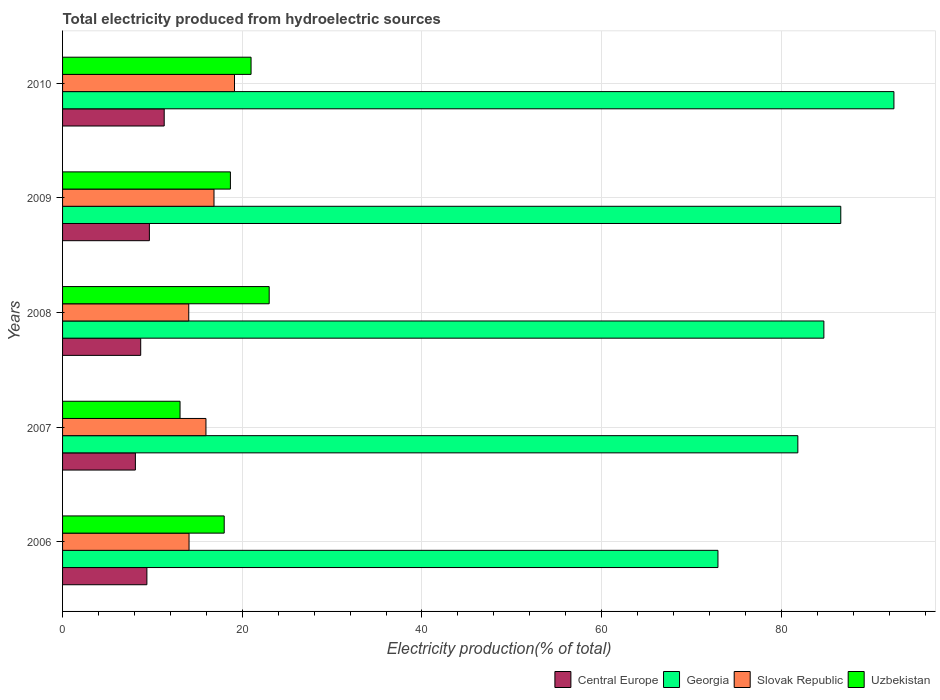How many groups of bars are there?
Offer a terse response. 5. Are the number of bars per tick equal to the number of legend labels?
Your answer should be very brief. Yes. What is the label of the 4th group of bars from the top?
Ensure brevity in your answer.  2007. In how many cases, is the number of bars for a given year not equal to the number of legend labels?
Give a very brief answer. 0. What is the total electricity produced in Georgia in 2007?
Provide a succinct answer. 81.83. Across all years, what is the maximum total electricity produced in Georgia?
Give a very brief answer. 92.52. Across all years, what is the minimum total electricity produced in Uzbekistan?
Make the answer very short. 13.07. In which year was the total electricity produced in Central Europe minimum?
Ensure brevity in your answer.  2007. What is the total total electricity produced in Central Europe in the graph?
Provide a short and direct response. 47.16. What is the difference between the total electricity produced in Georgia in 2006 and that in 2010?
Make the answer very short. -19.58. What is the difference between the total electricity produced in Uzbekistan in 2010 and the total electricity produced in Central Europe in 2008?
Give a very brief answer. 12.28. What is the average total electricity produced in Slovak Republic per year?
Ensure brevity in your answer.  16.01. In the year 2010, what is the difference between the total electricity produced in Central Europe and total electricity produced in Slovak Republic?
Your answer should be very brief. -7.82. In how many years, is the total electricity produced in Central Europe greater than 84 %?
Your answer should be very brief. 0. What is the ratio of the total electricity produced in Central Europe in 2006 to that in 2010?
Provide a succinct answer. 0.83. Is the total electricity produced in Uzbekistan in 2006 less than that in 2009?
Ensure brevity in your answer.  Yes. Is the difference between the total electricity produced in Central Europe in 2006 and 2010 greater than the difference between the total electricity produced in Slovak Republic in 2006 and 2010?
Your answer should be compact. Yes. What is the difference between the highest and the second highest total electricity produced in Central Europe?
Keep it short and to the point. 1.65. What is the difference between the highest and the lowest total electricity produced in Uzbekistan?
Keep it short and to the point. 9.92. Is it the case that in every year, the sum of the total electricity produced in Slovak Republic and total electricity produced in Georgia is greater than the sum of total electricity produced in Central Europe and total electricity produced in Uzbekistan?
Give a very brief answer. Yes. What does the 3rd bar from the top in 2006 represents?
Offer a very short reply. Georgia. What does the 4th bar from the bottom in 2006 represents?
Your response must be concise. Uzbekistan. Is it the case that in every year, the sum of the total electricity produced in Georgia and total electricity produced in Uzbekistan is greater than the total electricity produced in Slovak Republic?
Ensure brevity in your answer.  Yes. How many bars are there?
Offer a terse response. 20. Are all the bars in the graph horizontal?
Make the answer very short. Yes. How many years are there in the graph?
Ensure brevity in your answer.  5. What is the difference between two consecutive major ticks on the X-axis?
Give a very brief answer. 20. Does the graph contain any zero values?
Your answer should be compact. No. Does the graph contain grids?
Your answer should be compact. Yes. Where does the legend appear in the graph?
Provide a succinct answer. Bottom right. How many legend labels are there?
Provide a short and direct response. 4. How are the legend labels stacked?
Offer a very short reply. Horizontal. What is the title of the graph?
Ensure brevity in your answer.  Total electricity produced from hydroelectric sources. What is the Electricity production(% of total) in Central Europe in 2006?
Provide a short and direct response. 9.39. What is the Electricity production(% of total) in Georgia in 2006?
Ensure brevity in your answer.  72.94. What is the Electricity production(% of total) in Slovak Republic in 2006?
Your answer should be very brief. 14.08. What is the Electricity production(% of total) in Uzbekistan in 2006?
Your response must be concise. 17.99. What is the Electricity production(% of total) in Central Europe in 2007?
Your response must be concise. 8.1. What is the Electricity production(% of total) of Georgia in 2007?
Your answer should be compact. 81.83. What is the Electricity production(% of total) of Slovak Republic in 2007?
Ensure brevity in your answer.  15.96. What is the Electricity production(% of total) of Uzbekistan in 2007?
Make the answer very short. 13.07. What is the Electricity production(% of total) of Central Europe in 2008?
Ensure brevity in your answer.  8.7. What is the Electricity production(% of total) of Georgia in 2008?
Provide a short and direct response. 84.73. What is the Electricity production(% of total) in Slovak Republic in 2008?
Offer a terse response. 14.04. What is the Electricity production(% of total) in Uzbekistan in 2008?
Your answer should be compact. 23. What is the Electricity production(% of total) in Central Europe in 2009?
Provide a succinct answer. 9.66. What is the Electricity production(% of total) of Georgia in 2009?
Give a very brief answer. 86.61. What is the Electricity production(% of total) in Slovak Republic in 2009?
Provide a short and direct response. 16.85. What is the Electricity production(% of total) in Uzbekistan in 2009?
Provide a succinct answer. 18.68. What is the Electricity production(% of total) of Central Europe in 2010?
Make the answer very short. 11.31. What is the Electricity production(% of total) of Georgia in 2010?
Give a very brief answer. 92.52. What is the Electricity production(% of total) in Slovak Republic in 2010?
Keep it short and to the point. 19.13. What is the Electricity production(% of total) of Uzbekistan in 2010?
Your answer should be very brief. 20.98. Across all years, what is the maximum Electricity production(% of total) in Central Europe?
Ensure brevity in your answer.  11.31. Across all years, what is the maximum Electricity production(% of total) of Georgia?
Ensure brevity in your answer.  92.52. Across all years, what is the maximum Electricity production(% of total) in Slovak Republic?
Keep it short and to the point. 19.13. Across all years, what is the maximum Electricity production(% of total) in Uzbekistan?
Provide a succinct answer. 23. Across all years, what is the minimum Electricity production(% of total) of Central Europe?
Make the answer very short. 8.1. Across all years, what is the minimum Electricity production(% of total) of Georgia?
Provide a short and direct response. 72.94. Across all years, what is the minimum Electricity production(% of total) of Slovak Republic?
Give a very brief answer. 14.04. Across all years, what is the minimum Electricity production(% of total) of Uzbekistan?
Give a very brief answer. 13.07. What is the total Electricity production(% of total) in Central Europe in the graph?
Give a very brief answer. 47.16. What is the total Electricity production(% of total) of Georgia in the graph?
Give a very brief answer. 418.63. What is the total Electricity production(% of total) in Slovak Republic in the graph?
Your answer should be very brief. 80.06. What is the total Electricity production(% of total) in Uzbekistan in the graph?
Ensure brevity in your answer.  93.72. What is the difference between the Electricity production(% of total) of Central Europe in 2006 and that in 2007?
Keep it short and to the point. 1.28. What is the difference between the Electricity production(% of total) of Georgia in 2006 and that in 2007?
Provide a succinct answer. -8.89. What is the difference between the Electricity production(% of total) in Slovak Republic in 2006 and that in 2007?
Offer a terse response. -1.88. What is the difference between the Electricity production(% of total) in Uzbekistan in 2006 and that in 2007?
Your response must be concise. 4.91. What is the difference between the Electricity production(% of total) of Central Europe in 2006 and that in 2008?
Provide a succinct answer. 0.69. What is the difference between the Electricity production(% of total) of Georgia in 2006 and that in 2008?
Offer a very short reply. -11.79. What is the difference between the Electricity production(% of total) of Slovak Republic in 2006 and that in 2008?
Provide a short and direct response. 0.03. What is the difference between the Electricity production(% of total) of Uzbekistan in 2006 and that in 2008?
Keep it short and to the point. -5.01. What is the difference between the Electricity production(% of total) in Central Europe in 2006 and that in 2009?
Make the answer very short. -0.28. What is the difference between the Electricity production(% of total) in Georgia in 2006 and that in 2009?
Make the answer very short. -13.67. What is the difference between the Electricity production(% of total) of Slovak Republic in 2006 and that in 2009?
Your answer should be very brief. -2.78. What is the difference between the Electricity production(% of total) in Uzbekistan in 2006 and that in 2009?
Provide a succinct answer. -0.69. What is the difference between the Electricity production(% of total) in Central Europe in 2006 and that in 2010?
Offer a terse response. -1.93. What is the difference between the Electricity production(% of total) in Georgia in 2006 and that in 2010?
Your answer should be compact. -19.58. What is the difference between the Electricity production(% of total) in Slovak Republic in 2006 and that in 2010?
Your response must be concise. -5.06. What is the difference between the Electricity production(% of total) in Uzbekistan in 2006 and that in 2010?
Ensure brevity in your answer.  -2.99. What is the difference between the Electricity production(% of total) of Central Europe in 2007 and that in 2008?
Make the answer very short. -0.59. What is the difference between the Electricity production(% of total) of Georgia in 2007 and that in 2008?
Your answer should be very brief. -2.9. What is the difference between the Electricity production(% of total) in Slovak Republic in 2007 and that in 2008?
Provide a short and direct response. 1.91. What is the difference between the Electricity production(% of total) in Uzbekistan in 2007 and that in 2008?
Give a very brief answer. -9.92. What is the difference between the Electricity production(% of total) in Central Europe in 2007 and that in 2009?
Your answer should be compact. -1.56. What is the difference between the Electricity production(% of total) of Georgia in 2007 and that in 2009?
Ensure brevity in your answer.  -4.78. What is the difference between the Electricity production(% of total) in Slovak Republic in 2007 and that in 2009?
Provide a succinct answer. -0.89. What is the difference between the Electricity production(% of total) in Uzbekistan in 2007 and that in 2009?
Your answer should be compact. -5.6. What is the difference between the Electricity production(% of total) in Central Europe in 2007 and that in 2010?
Provide a short and direct response. -3.21. What is the difference between the Electricity production(% of total) of Georgia in 2007 and that in 2010?
Provide a short and direct response. -10.69. What is the difference between the Electricity production(% of total) in Slovak Republic in 2007 and that in 2010?
Ensure brevity in your answer.  -3.18. What is the difference between the Electricity production(% of total) of Uzbekistan in 2007 and that in 2010?
Your answer should be compact. -7.9. What is the difference between the Electricity production(% of total) of Central Europe in 2008 and that in 2009?
Give a very brief answer. -0.97. What is the difference between the Electricity production(% of total) in Georgia in 2008 and that in 2009?
Give a very brief answer. -1.88. What is the difference between the Electricity production(% of total) in Slovak Republic in 2008 and that in 2009?
Your answer should be compact. -2.81. What is the difference between the Electricity production(% of total) in Uzbekistan in 2008 and that in 2009?
Offer a terse response. 4.32. What is the difference between the Electricity production(% of total) in Central Europe in 2008 and that in 2010?
Provide a succinct answer. -2.62. What is the difference between the Electricity production(% of total) of Georgia in 2008 and that in 2010?
Provide a succinct answer. -7.8. What is the difference between the Electricity production(% of total) in Slovak Republic in 2008 and that in 2010?
Provide a succinct answer. -5.09. What is the difference between the Electricity production(% of total) in Uzbekistan in 2008 and that in 2010?
Your answer should be compact. 2.02. What is the difference between the Electricity production(% of total) in Central Europe in 2009 and that in 2010?
Make the answer very short. -1.65. What is the difference between the Electricity production(% of total) of Georgia in 2009 and that in 2010?
Your answer should be very brief. -5.91. What is the difference between the Electricity production(% of total) of Slovak Republic in 2009 and that in 2010?
Keep it short and to the point. -2.28. What is the difference between the Electricity production(% of total) in Central Europe in 2006 and the Electricity production(% of total) in Georgia in 2007?
Offer a very short reply. -72.44. What is the difference between the Electricity production(% of total) of Central Europe in 2006 and the Electricity production(% of total) of Slovak Republic in 2007?
Provide a succinct answer. -6.57. What is the difference between the Electricity production(% of total) in Central Europe in 2006 and the Electricity production(% of total) in Uzbekistan in 2007?
Give a very brief answer. -3.69. What is the difference between the Electricity production(% of total) in Georgia in 2006 and the Electricity production(% of total) in Slovak Republic in 2007?
Your answer should be compact. 56.98. What is the difference between the Electricity production(% of total) of Georgia in 2006 and the Electricity production(% of total) of Uzbekistan in 2007?
Give a very brief answer. 59.86. What is the difference between the Electricity production(% of total) of Central Europe in 2006 and the Electricity production(% of total) of Georgia in 2008?
Your answer should be very brief. -75.34. What is the difference between the Electricity production(% of total) in Central Europe in 2006 and the Electricity production(% of total) in Slovak Republic in 2008?
Provide a succinct answer. -4.66. What is the difference between the Electricity production(% of total) in Central Europe in 2006 and the Electricity production(% of total) in Uzbekistan in 2008?
Provide a short and direct response. -13.61. What is the difference between the Electricity production(% of total) in Georgia in 2006 and the Electricity production(% of total) in Slovak Republic in 2008?
Give a very brief answer. 58.89. What is the difference between the Electricity production(% of total) of Georgia in 2006 and the Electricity production(% of total) of Uzbekistan in 2008?
Your response must be concise. 49.94. What is the difference between the Electricity production(% of total) of Slovak Republic in 2006 and the Electricity production(% of total) of Uzbekistan in 2008?
Make the answer very short. -8.92. What is the difference between the Electricity production(% of total) in Central Europe in 2006 and the Electricity production(% of total) in Georgia in 2009?
Make the answer very short. -77.22. What is the difference between the Electricity production(% of total) in Central Europe in 2006 and the Electricity production(% of total) in Slovak Republic in 2009?
Your answer should be very brief. -7.47. What is the difference between the Electricity production(% of total) in Central Europe in 2006 and the Electricity production(% of total) in Uzbekistan in 2009?
Ensure brevity in your answer.  -9.29. What is the difference between the Electricity production(% of total) of Georgia in 2006 and the Electricity production(% of total) of Slovak Republic in 2009?
Provide a short and direct response. 56.09. What is the difference between the Electricity production(% of total) of Georgia in 2006 and the Electricity production(% of total) of Uzbekistan in 2009?
Provide a short and direct response. 54.26. What is the difference between the Electricity production(% of total) of Slovak Republic in 2006 and the Electricity production(% of total) of Uzbekistan in 2009?
Your answer should be very brief. -4.6. What is the difference between the Electricity production(% of total) in Central Europe in 2006 and the Electricity production(% of total) in Georgia in 2010?
Offer a terse response. -83.14. What is the difference between the Electricity production(% of total) of Central Europe in 2006 and the Electricity production(% of total) of Slovak Republic in 2010?
Offer a terse response. -9.75. What is the difference between the Electricity production(% of total) in Central Europe in 2006 and the Electricity production(% of total) in Uzbekistan in 2010?
Provide a short and direct response. -11.59. What is the difference between the Electricity production(% of total) in Georgia in 2006 and the Electricity production(% of total) in Slovak Republic in 2010?
Give a very brief answer. 53.8. What is the difference between the Electricity production(% of total) in Georgia in 2006 and the Electricity production(% of total) in Uzbekistan in 2010?
Your response must be concise. 51.96. What is the difference between the Electricity production(% of total) of Slovak Republic in 2006 and the Electricity production(% of total) of Uzbekistan in 2010?
Provide a short and direct response. -6.9. What is the difference between the Electricity production(% of total) in Central Europe in 2007 and the Electricity production(% of total) in Georgia in 2008?
Provide a succinct answer. -76.62. What is the difference between the Electricity production(% of total) of Central Europe in 2007 and the Electricity production(% of total) of Slovak Republic in 2008?
Your answer should be compact. -5.94. What is the difference between the Electricity production(% of total) of Central Europe in 2007 and the Electricity production(% of total) of Uzbekistan in 2008?
Provide a succinct answer. -14.89. What is the difference between the Electricity production(% of total) in Georgia in 2007 and the Electricity production(% of total) in Slovak Republic in 2008?
Keep it short and to the point. 67.79. What is the difference between the Electricity production(% of total) of Georgia in 2007 and the Electricity production(% of total) of Uzbekistan in 2008?
Provide a short and direct response. 58.83. What is the difference between the Electricity production(% of total) in Slovak Republic in 2007 and the Electricity production(% of total) in Uzbekistan in 2008?
Your answer should be very brief. -7.04. What is the difference between the Electricity production(% of total) of Central Europe in 2007 and the Electricity production(% of total) of Georgia in 2009?
Make the answer very short. -78.5. What is the difference between the Electricity production(% of total) of Central Europe in 2007 and the Electricity production(% of total) of Slovak Republic in 2009?
Your response must be concise. -8.75. What is the difference between the Electricity production(% of total) in Central Europe in 2007 and the Electricity production(% of total) in Uzbekistan in 2009?
Provide a short and direct response. -10.57. What is the difference between the Electricity production(% of total) of Georgia in 2007 and the Electricity production(% of total) of Slovak Republic in 2009?
Offer a very short reply. 64.98. What is the difference between the Electricity production(% of total) in Georgia in 2007 and the Electricity production(% of total) in Uzbekistan in 2009?
Your response must be concise. 63.15. What is the difference between the Electricity production(% of total) of Slovak Republic in 2007 and the Electricity production(% of total) of Uzbekistan in 2009?
Make the answer very short. -2.72. What is the difference between the Electricity production(% of total) in Central Europe in 2007 and the Electricity production(% of total) in Georgia in 2010?
Ensure brevity in your answer.  -84.42. What is the difference between the Electricity production(% of total) in Central Europe in 2007 and the Electricity production(% of total) in Slovak Republic in 2010?
Give a very brief answer. -11.03. What is the difference between the Electricity production(% of total) of Central Europe in 2007 and the Electricity production(% of total) of Uzbekistan in 2010?
Provide a succinct answer. -12.87. What is the difference between the Electricity production(% of total) of Georgia in 2007 and the Electricity production(% of total) of Slovak Republic in 2010?
Provide a short and direct response. 62.7. What is the difference between the Electricity production(% of total) of Georgia in 2007 and the Electricity production(% of total) of Uzbekistan in 2010?
Keep it short and to the point. 60.85. What is the difference between the Electricity production(% of total) in Slovak Republic in 2007 and the Electricity production(% of total) in Uzbekistan in 2010?
Your answer should be very brief. -5.02. What is the difference between the Electricity production(% of total) of Central Europe in 2008 and the Electricity production(% of total) of Georgia in 2009?
Provide a short and direct response. -77.91. What is the difference between the Electricity production(% of total) of Central Europe in 2008 and the Electricity production(% of total) of Slovak Republic in 2009?
Provide a short and direct response. -8.16. What is the difference between the Electricity production(% of total) of Central Europe in 2008 and the Electricity production(% of total) of Uzbekistan in 2009?
Your response must be concise. -9.98. What is the difference between the Electricity production(% of total) in Georgia in 2008 and the Electricity production(% of total) in Slovak Republic in 2009?
Your answer should be very brief. 67.87. What is the difference between the Electricity production(% of total) of Georgia in 2008 and the Electricity production(% of total) of Uzbekistan in 2009?
Give a very brief answer. 66.05. What is the difference between the Electricity production(% of total) in Slovak Republic in 2008 and the Electricity production(% of total) in Uzbekistan in 2009?
Your answer should be very brief. -4.63. What is the difference between the Electricity production(% of total) of Central Europe in 2008 and the Electricity production(% of total) of Georgia in 2010?
Keep it short and to the point. -83.83. What is the difference between the Electricity production(% of total) of Central Europe in 2008 and the Electricity production(% of total) of Slovak Republic in 2010?
Offer a very short reply. -10.44. What is the difference between the Electricity production(% of total) of Central Europe in 2008 and the Electricity production(% of total) of Uzbekistan in 2010?
Keep it short and to the point. -12.28. What is the difference between the Electricity production(% of total) of Georgia in 2008 and the Electricity production(% of total) of Slovak Republic in 2010?
Provide a short and direct response. 65.59. What is the difference between the Electricity production(% of total) of Georgia in 2008 and the Electricity production(% of total) of Uzbekistan in 2010?
Offer a very short reply. 63.75. What is the difference between the Electricity production(% of total) of Slovak Republic in 2008 and the Electricity production(% of total) of Uzbekistan in 2010?
Provide a succinct answer. -6.93. What is the difference between the Electricity production(% of total) in Central Europe in 2009 and the Electricity production(% of total) in Georgia in 2010?
Offer a very short reply. -82.86. What is the difference between the Electricity production(% of total) of Central Europe in 2009 and the Electricity production(% of total) of Slovak Republic in 2010?
Offer a very short reply. -9.47. What is the difference between the Electricity production(% of total) of Central Europe in 2009 and the Electricity production(% of total) of Uzbekistan in 2010?
Make the answer very short. -11.32. What is the difference between the Electricity production(% of total) in Georgia in 2009 and the Electricity production(% of total) in Slovak Republic in 2010?
Offer a very short reply. 67.47. What is the difference between the Electricity production(% of total) of Georgia in 2009 and the Electricity production(% of total) of Uzbekistan in 2010?
Offer a terse response. 65.63. What is the difference between the Electricity production(% of total) of Slovak Republic in 2009 and the Electricity production(% of total) of Uzbekistan in 2010?
Make the answer very short. -4.13. What is the average Electricity production(% of total) of Central Europe per year?
Your answer should be compact. 9.43. What is the average Electricity production(% of total) in Georgia per year?
Provide a succinct answer. 83.73. What is the average Electricity production(% of total) in Slovak Republic per year?
Ensure brevity in your answer.  16.01. What is the average Electricity production(% of total) of Uzbekistan per year?
Make the answer very short. 18.74. In the year 2006, what is the difference between the Electricity production(% of total) of Central Europe and Electricity production(% of total) of Georgia?
Make the answer very short. -63.55. In the year 2006, what is the difference between the Electricity production(% of total) in Central Europe and Electricity production(% of total) in Slovak Republic?
Provide a succinct answer. -4.69. In the year 2006, what is the difference between the Electricity production(% of total) of Central Europe and Electricity production(% of total) of Uzbekistan?
Ensure brevity in your answer.  -8.6. In the year 2006, what is the difference between the Electricity production(% of total) of Georgia and Electricity production(% of total) of Slovak Republic?
Offer a very short reply. 58.86. In the year 2006, what is the difference between the Electricity production(% of total) of Georgia and Electricity production(% of total) of Uzbekistan?
Provide a succinct answer. 54.95. In the year 2006, what is the difference between the Electricity production(% of total) of Slovak Republic and Electricity production(% of total) of Uzbekistan?
Make the answer very short. -3.91. In the year 2007, what is the difference between the Electricity production(% of total) in Central Europe and Electricity production(% of total) in Georgia?
Ensure brevity in your answer.  -73.73. In the year 2007, what is the difference between the Electricity production(% of total) of Central Europe and Electricity production(% of total) of Slovak Republic?
Your answer should be compact. -7.85. In the year 2007, what is the difference between the Electricity production(% of total) of Central Europe and Electricity production(% of total) of Uzbekistan?
Offer a very short reply. -4.97. In the year 2007, what is the difference between the Electricity production(% of total) of Georgia and Electricity production(% of total) of Slovak Republic?
Keep it short and to the point. 65.87. In the year 2007, what is the difference between the Electricity production(% of total) of Georgia and Electricity production(% of total) of Uzbekistan?
Provide a short and direct response. 68.75. In the year 2007, what is the difference between the Electricity production(% of total) in Slovak Republic and Electricity production(% of total) in Uzbekistan?
Provide a succinct answer. 2.88. In the year 2008, what is the difference between the Electricity production(% of total) in Central Europe and Electricity production(% of total) in Georgia?
Make the answer very short. -76.03. In the year 2008, what is the difference between the Electricity production(% of total) of Central Europe and Electricity production(% of total) of Slovak Republic?
Offer a terse response. -5.35. In the year 2008, what is the difference between the Electricity production(% of total) of Central Europe and Electricity production(% of total) of Uzbekistan?
Provide a short and direct response. -14.3. In the year 2008, what is the difference between the Electricity production(% of total) of Georgia and Electricity production(% of total) of Slovak Republic?
Your answer should be compact. 70.68. In the year 2008, what is the difference between the Electricity production(% of total) of Georgia and Electricity production(% of total) of Uzbekistan?
Your answer should be very brief. 61.73. In the year 2008, what is the difference between the Electricity production(% of total) in Slovak Republic and Electricity production(% of total) in Uzbekistan?
Your answer should be compact. -8.95. In the year 2009, what is the difference between the Electricity production(% of total) of Central Europe and Electricity production(% of total) of Georgia?
Ensure brevity in your answer.  -76.95. In the year 2009, what is the difference between the Electricity production(% of total) in Central Europe and Electricity production(% of total) in Slovak Republic?
Your answer should be very brief. -7.19. In the year 2009, what is the difference between the Electricity production(% of total) of Central Europe and Electricity production(% of total) of Uzbekistan?
Your response must be concise. -9.02. In the year 2009, what is the difference between the Electricity production(% of total) of Georgia and Electricity production(% of total) of Slovak Republic?
Your response must be concise. 69.76. In the year 2009, what is the difference between the Electricity production(% of total) of Georgia and Electricity production(% of total) of Uzbekistan?
Your response must be concise. 67.93. In the year 2009, what is the difference between the Electricity production(% of total) of Slovak Republic and Electricity production(% of total) of Uzbekistan?
Offer a very short reply. -1.83. In the year 2010, what is the difference between the Electricity production(% of total) of Central Europe and Electricity production(% of total) of Georgia?
Offer a very short reply. -81.21. In the year 2010, what is the difference between the Electricity production(% of total) of Central Europe and Electricity production(% of total) of Slovak Republic?
Provide a short and direct response. -7.82. In the year 2010, what is the difference between the Electricity production(% of total) in Central Europe and Electricity production(% of total) in Uzbekistan?
Your response must be concise. -9.67. In the year 2010, what is the difference between the Electricity production(% of total) in Georgia and Electricity production(% of total) in Slovak Republic?
Your answer should be very brief. 73.39. In the year 2010, what is the difference between the Electricity production(% of total) of Georgia and Electricity production(% of total) of Uzbekistan?
Provide a short and direct response. 71.54. In the year 2010, what is the difference between the Electricity production(% of total) in Slovak Republic and Electricity production(% of total) in Uzbekistan?
Ensure brevity in your answer.  -1.84. What is the ratio of the Electricity production(% of total) in Central Europe in 2006 to that in 2007?
Offer a very short reply. 1.16. What is the ratio of the Electricity production(% of total) of Georgia in 2006 to that in 2007?
Keep it short and to the point. 0.89. What is the ratio of the Electricity production(% of total) of Slovak Republic in 2006 to that in 2007?
Give a very brief answer. 0.88. What is the ratio of the Electricity production(% of total) in Uzbekistan in 2006 to that in 2007?
Offer a terse response. 1.38. What is the ratio of the Electricity production(% of total) in Central Europe in 2006 to that in 2008?
Your answer should be very brief. 1.08. What is the ratio of the Electricity production(% of total) in Georgia in 2006 to that in 2008?
Keep it short and to the point. 0.86. What is the ratio of the Electricity production(% of total) in Slovak Republic in 2006 to that in 2008?
Make the answer very short. 1. What is the ratio of the Electricity production(% of total) of Uzbekistan in 2006 to that in 2008?
Give a very brief answer. 0.78. What is the ratio of the Electricity production(% of total) of Central Europe in 2006 to that in 2009?
Keep it short and to the point. 0.97. What is the ratio of the Electricity production(% of total) in Georgia in 2006 to that in 2009?
Keep it short and to the point. 0.84. What is the ratio of the Electricity production(% of total) in Slovak Republic in 2006 to that in 2009?
Make the answer very short. 0.84. What is the ratio of the Electricity production(% of total) of Uzbekistan in 2006 to that in 2009?
Your response must be concise. 0.96. What is the ratio of the Electricity production(% of total) in Central Europe in 2006 to that in 2010?
Your answer should be compact. 0.83. What is the ratio of the Electricity production(% of total) in Georgia in 2006 to that in 2010?
Offer a terse response. 0.79. What is the ratio of the Electricity production(% of total) in Slovak Republic in 2006 to that in 2010?
Make the answer very short. 0.74. What is the ratio of the Electricity production(% of total) in Uzbekistan in 2006 to that in 2010?
Give a very brief answer. 0.86. What is the ratio of the Electricity production(% of total) of Central Europe in 2007 to that in 2008?
Make the answer very short. 0.93. What is the ratio of the Electricity production(% of total) of Georgia in 2007 to that in 2008?
Give a very brief answer. 0.97. What is the ratio of the Electricity production(% of total) of Slovak Republic in 2007 to that in 2008?
Offer a very short reply. 1.14. What is the ratio of the Electricity production(% of total) of Uzbekistan in 2007 to that in 2008?
Keep it short and to the point. 0.57. What is the ratio of the Electricity production(% of total) in Central Europe in 2007 to that in 2009?
Offer a very short reply. 0.84. What is the ratio of the Electricity production(% of total) of Georgia in 2007 to that in 2009?
Offer a very short reply. 0.94. What is the ratio of the Electricity production(% of total) of Slovak Republic in 2007 to that in 2009?
Give a very brief answer. 0.95. What is the ratio of the Electricity production(% of total) in Central Europe in 2007 to that in 2010?
Your answer should be very brief. 0.72. What is the ratio of the Electricity production(% of total) in Georgia in 2007 to that in 2010?
Offer a terse response. 0.88. What is the ratio of the Electricity production(% of total) in Slovak Republic in 2007 to that in 2010?
Ensure brevity in your answer.  0.83. What is the ratio of the Electricity production(% of total) in Uzbekistan in 2007 to that in 2010?
Offer a terse response. 0.62. What is the ratio of the Electricity production(% of total) of Central Europe in 2008 to that in 2009?
Provide a short and direct response. 0.9. What is the ratio of the Electricity production(% of total) of Georgia in 2008 to that in 2009?
Offer a very short reply. 0.98. What is the ratio of the Electricity production(% of total) of Slovak Republic in 2008 to that in 2009?
Ensure brevity in your answer.  0.83. What is the ratio of the Electricity production(% of total) of Uzbekistan in 2008 to that in 2009?
Your response must be concise. 1.23. What is the ratio of the Electricity production(% of total) in Central Europe in 2008 to that in 2010?
Ensure brevity in your answer.  0.77. What is the ratio of the Electricity production(% of total) of Georgia in 2008 to that in 2010?
Provide a succinct answer. 0.92. What is the ratio of the Electricity production(% of total) of Slovak Republic in 2008 to that in 2010?
Ensure brevity in your answer.  0.73. What is the ratio of the Electricity production(% of total) of Uzbekistan in 2008 to that in 2010?
Your response must be concise. 1.1. What is the ratio of the Electricity production(% of total) of Central Europe in 2009 to that in 2010?
Ensure brevity in your answer.  0.85. What is the ratio of the Electricity production(% of total) in Georgia in 2009 to that in 2010?
Keep it short and to the point. 0.94. What is the ratio of the Electricity production(% of total) in Slovak Republic in 2009 to that in 2010?
Offer a very short reply. 0.88. What is the ratio of the Electricity production(% of total) of Uzbekistan in 2009 to that in 2010?
Ensure brevity in your answer.  0.89. What is the difference between the highest and the second highest Electricity production(% of total) of Central Europe?
Offer a terse response. 1.65. What is the difference between the highest and the second highest Electricity production(% of total) of Georgia?
Your answer should be very brief. 5.91. What is the difference between the highest and the second highest Electricity production(% of total) in Slovak Republic?
Your answer should be compact. 2.28. What is the difference between the highest and the second highest Electricity production(% of total) of Uzbekistan?
Provide a succinct answer. 2.02. What is the difference between the highest and the lowest Electricity production(% of total) in Central Europe?
Your answer should be compact. 3.21. What is the difference between the highest and the lowest Electricity production(% of total) of Georgia?
Offer a very short reply. 19.58. What is the difference between the highest and the lowest Electricity production(% of total) of Slovak Republic?
Give a very brief answer. 5.09. What is the difference between the highest and the lowest Electricity production(% of total) in Uzbekistan?
Ensure brevity in your answer.  9.92. 